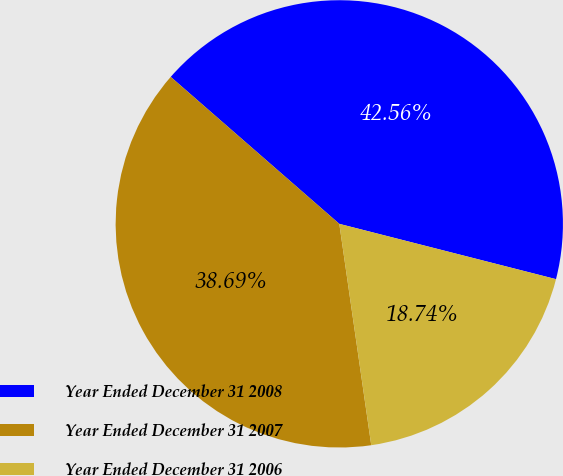Convert chart to OTSL. <chart><loc_0><loc_0><loc_500><loc_500><pie_chart><fcel>Year Ended December 31 2008<fcel>Year Ended December 31 2007<fcel>Year Ended December 31 2006<nl><fcel>42.56%<fcel>38.69%<fcel>18.74%<nl></chart> 